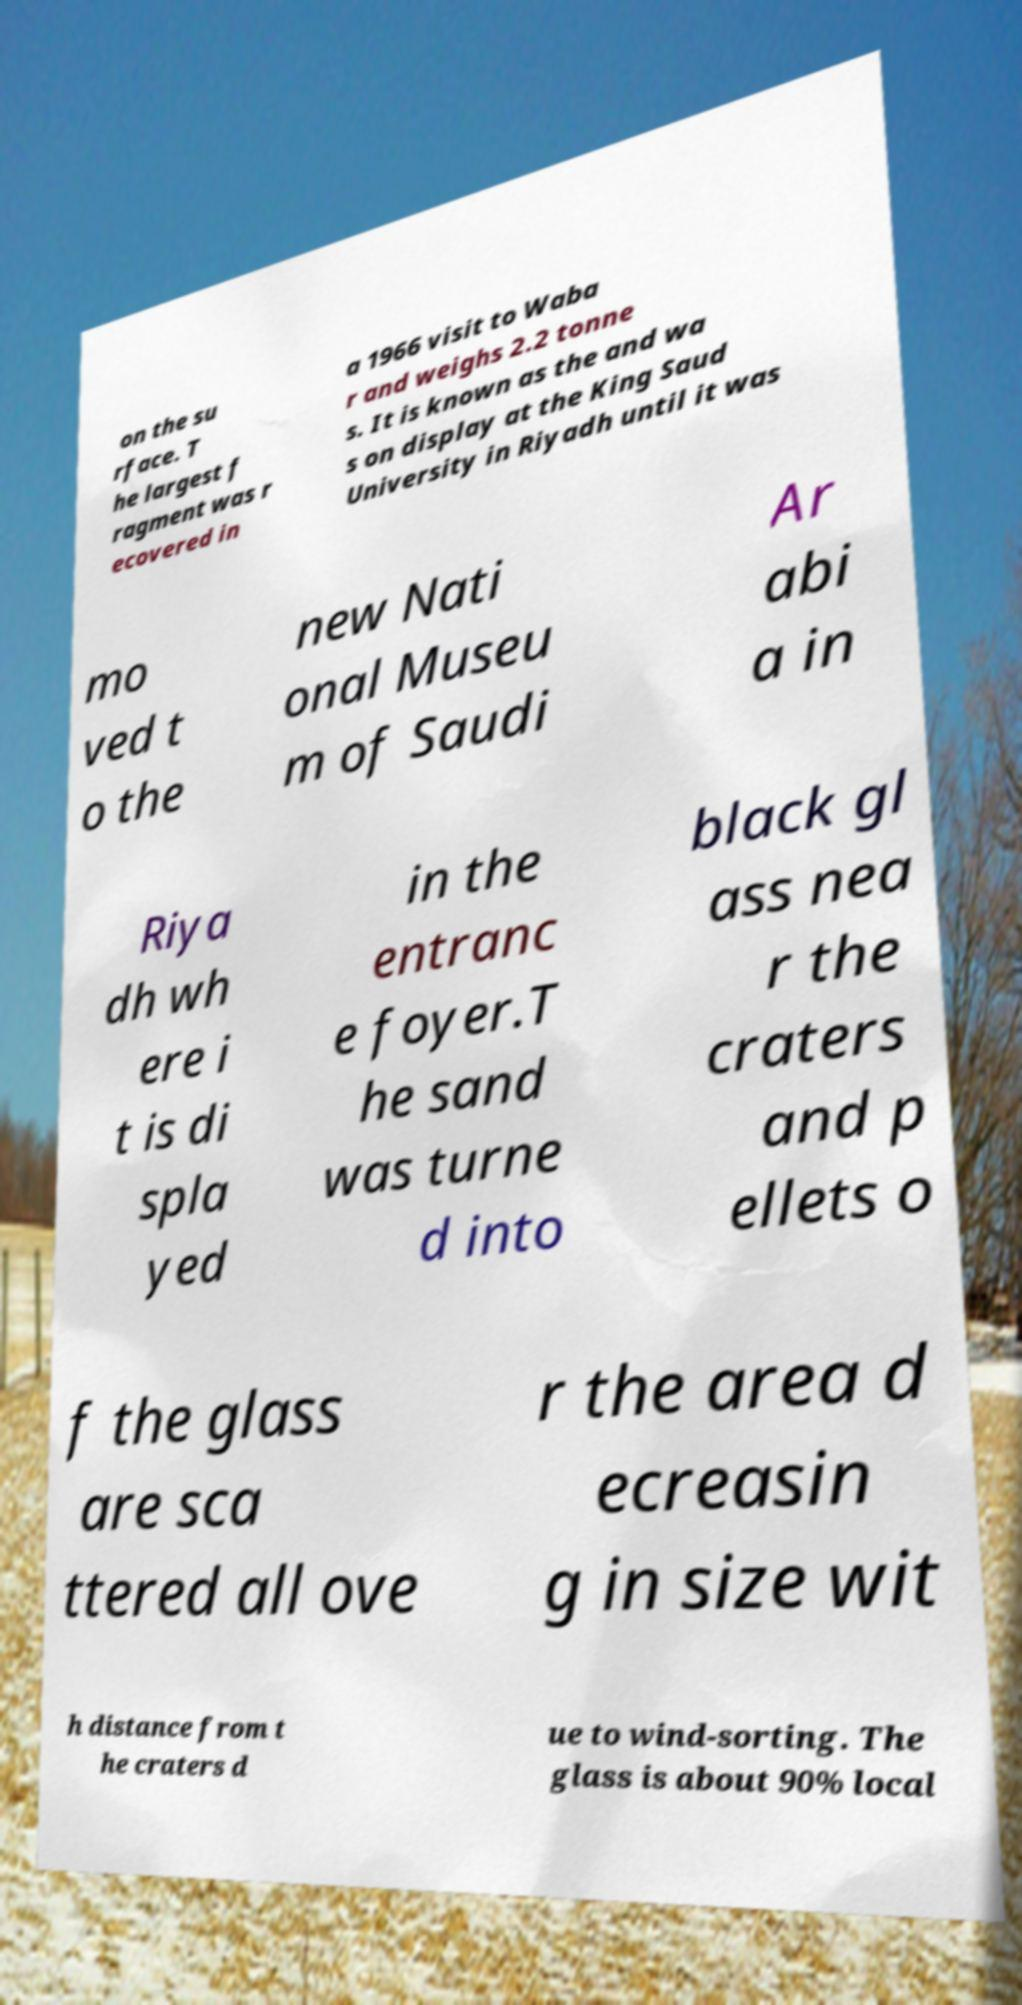Please read and relay the text visible in this image. What does it say? on the su rface. T he largest f ragment was r ecovered in a 1966 visit to Waba r and weighs 2.2 tonne s. It is known as the and wa s on display at the King Saud University in Riyadh until it was mo ved t o the new Nati onal Museu m of Saudi Ar abi a in Riya dh wh ere i t is di spla yed in the entranc e foyer.T he sand was turne d into black gl ass nea r the craters and p ellets o f the glass are sca ttered all ove r the area d ecreasin g in size wit h distance from t he craters d ue to wind-sorting. The glass is about 90% local 